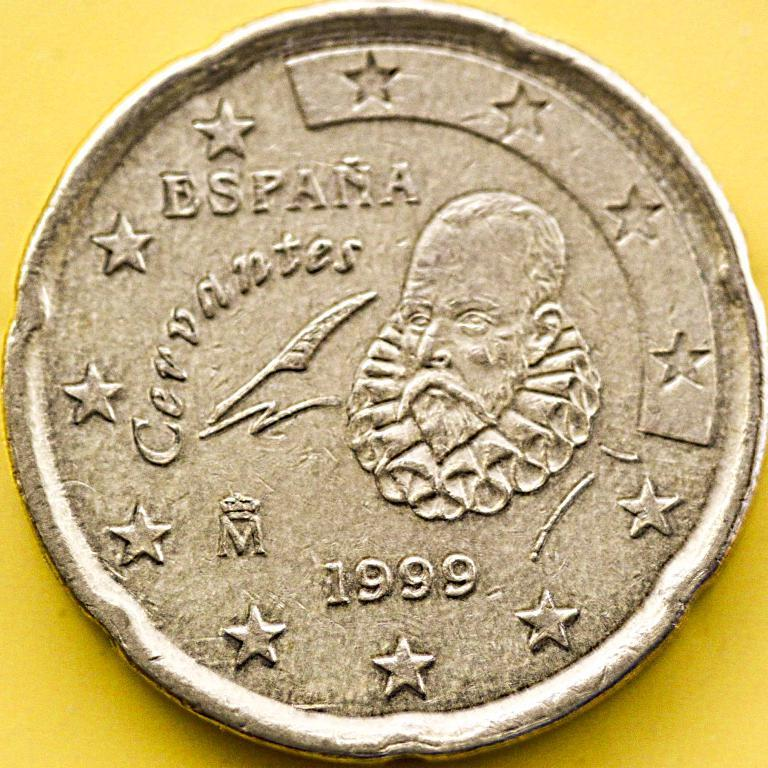<image>
Present a compact description of the photo's key features. an old brown coin thar reads espana cervantes 1999 